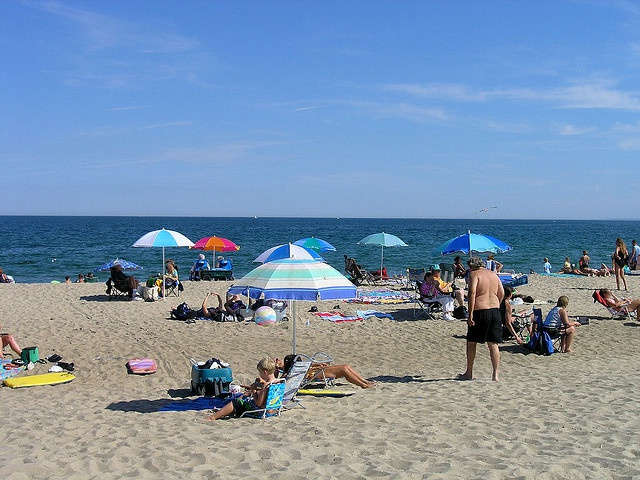Describe the objects in this image and their specific colors. I can see people in gray, black, darkgray, and blue tones, umbrella in gray, lightgray, lightblue, and darkgray tones, people in gray, black, tan, and maroon tones, people in gray, black, and maroon tones, and chair in gray, darkgray, and lightgray tones in this image. 